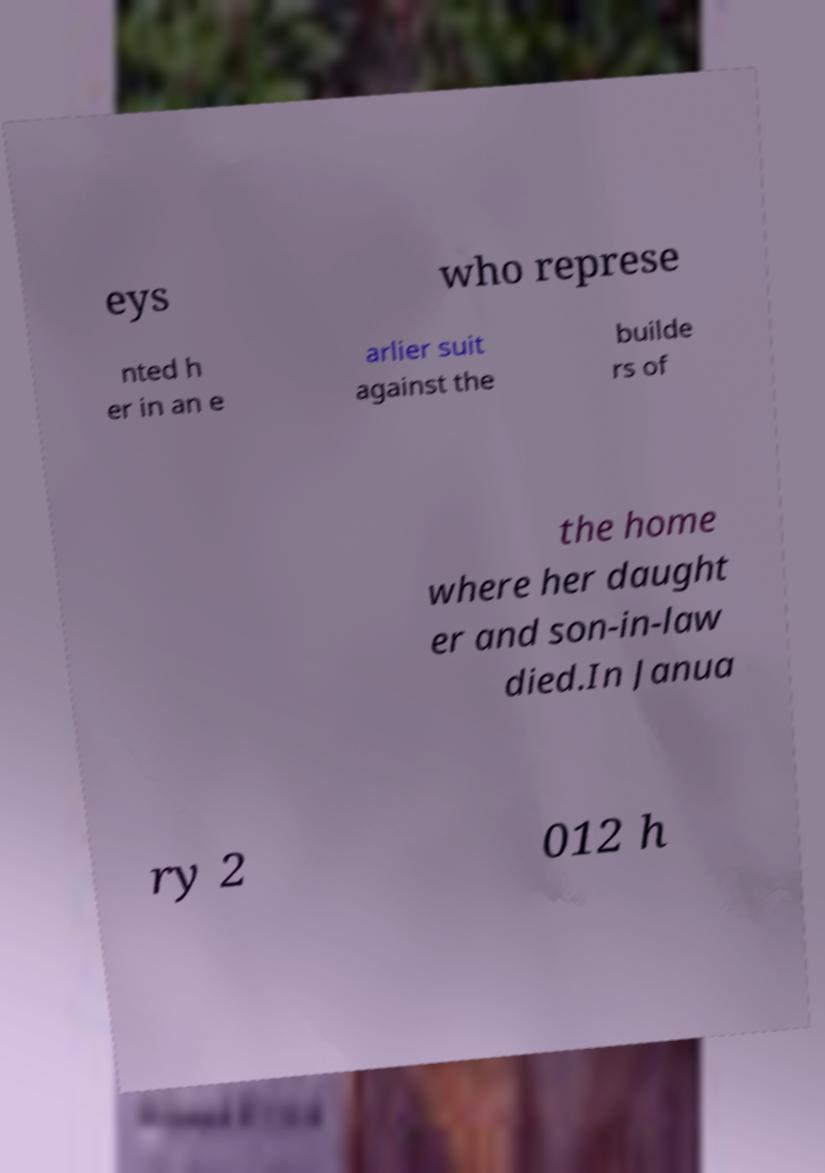Can you read and provide the text displayed in the image?This photo seems to have some interesting text. Can you extract and type it out for me? eys who represe nted h er in an e arlier suit against the builde rs of the home where her daught er and son-in-law died.In Janua ry 2 012 h 